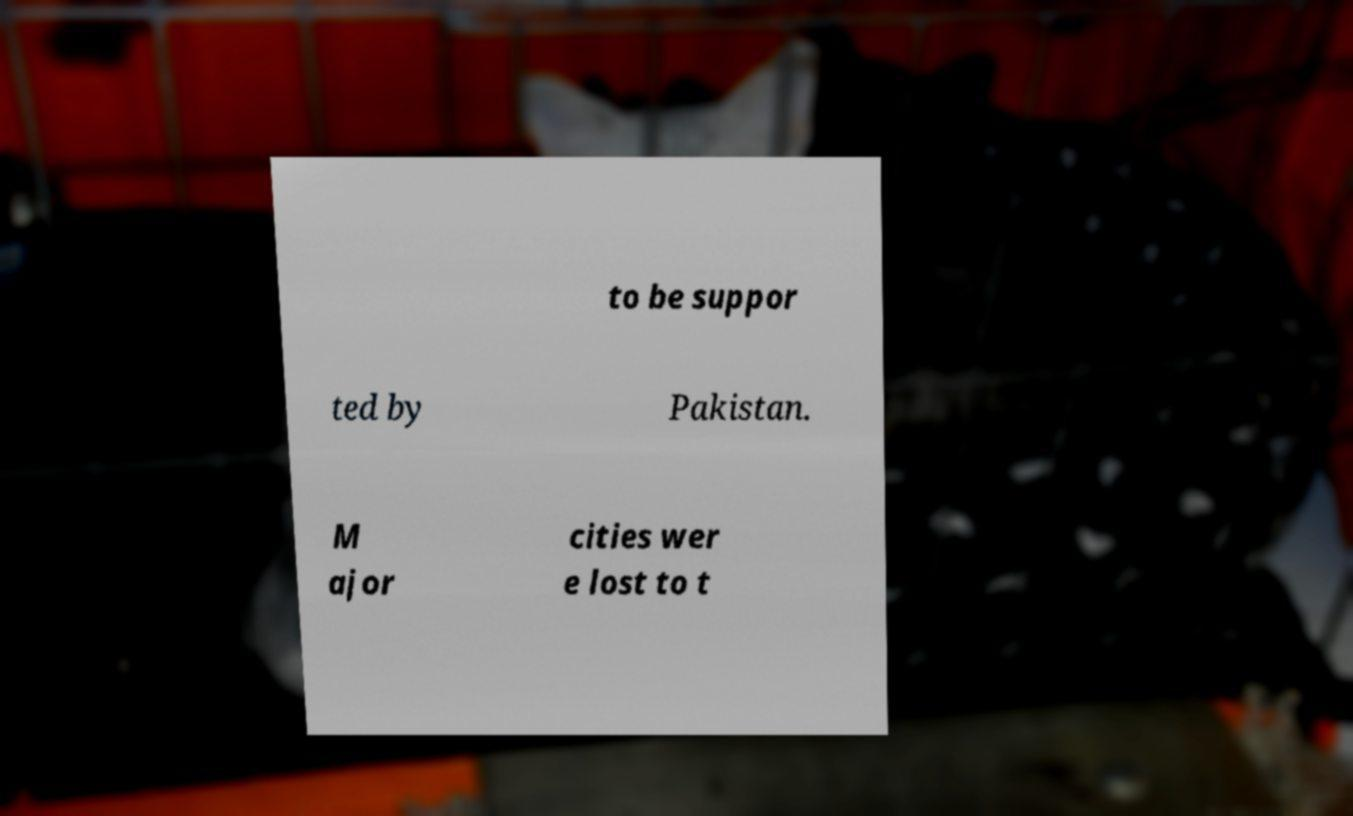Please read and relay the text visible in this image. What does it say? to be suppor ted by Pakistan. M ajor cities wer e lost to t 